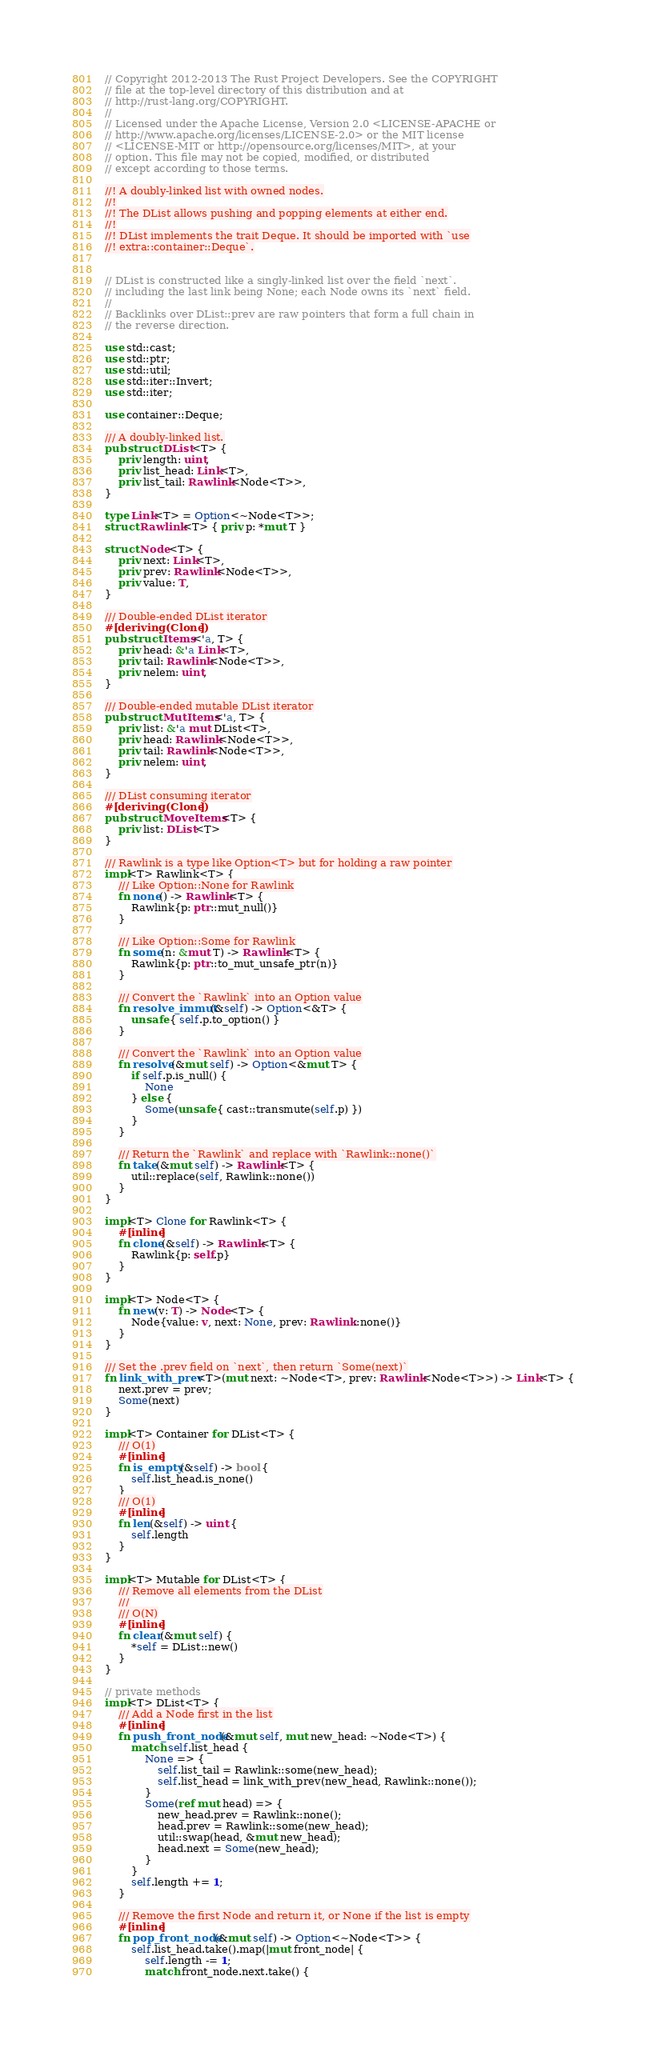Convert code to text. <code><loc_0><loc_0><loc_500><loc_500><_Rust_>// Copyright 2012-2013 The Rust Project Developers. See the COPYRIGHT
// file at the top-level directory of this distribution and at
// http://rust-lang.org/COPYRIGHT.
//
// Licensed under the Apache License, Version 2.0 <LICENSE-APACHE or
// http://www.apache.org/licenses/LICENSE-2.0> or the MIT license
// <LICENSE-MIT or http://opensource.org/licenses/MIT>, at your
// option. This file may not be copied, modified, or distributed
// except according to those terms.

//! A doubly-linked list with owned nodes.
//!
//! The DList allows pushing and popping elements at either end.
//!
//! DList implements the trait Deque. It should be imported with `use
//! extra::container::Deque`.


// DList is constructed like a singly-linked list over the field `next`.
// including the last link being None; each Node owns its `next` field.
//
// Backlinks over DList::prev are raw pointers that form a full chain in
// the reverse direction.

use std::cast;
use std::ptr;
use std::util;
use std::iter::Invert;
use std::iter;

use container::Deque;

/// A doubly-linked list.
pub struct DList<T> {
    priv length: uint,
    priv list_head: Link<T>,
    priv list_tail: Rawlink<Node<T>>,
}

type Link<T> = Option<~Node<T>>;
struct Rawlink<T> { priv p: *mut T }

struct Node<T> {
    priv next: Link<T>,
    priv prev: Rawlink<Node<T>>,
    priv value: T,
}

/// Double-ended DList iterator
#[deriving(Clone)]
pub struct Items<'a, T> {
    priv head: &'a Link<T>,
    priv tail: Rawlink<Node<T>>,
    priv nelem: uint,
}

/// Double-ended mutable DList iterator
pub struct MutItems<'a, T> {
    priv list: &'a mut DList<T>,
    priv head: Rawlink<Node<T>>,
    priv tail: Rawlink<Node<T>>,
    priv nelem: uint,
}

/// DList consuming iterator
#[deriving(Clone)]
pub struct MoveItems<T> {
    priv list: DList<T>
}

/// Rawlink is a type like Option<T> but for holding a raw pointer
impl<T> Rawlink<T> {
    /// Like Option::None for Rawlink
    fn none() -> Rawlink<T> {
        Rawlink{p: ptr::mut_null()}
    }

    /// Like Option::Some for Rawlink
    fn some(n: &mut T) -> Rawlink<T> {
        Rawlink{p: ptr::to_mut_unsafe_ptr(n)}
    }

    /// Convert the `Rawlink` into an Option value
    fn resolve_immut(&self) -> Option<&T> {
        unsafe { self.p.to_option() }
    }

    /// Convert the `Rawlink` into an Option value
    fn resolve(&mut self) -> Option<&mut T> {
        if self.p.is_null() {
            None
        } else {
            Some(unsafe { cast::transmute(self.p) })
        }
    }

    /// Return the `Rawlink` and replace with `Rawlink::none()`
    fn take(&mut self) -> Rawlink<T> {
        util::replace(self, Rawlink::none())
    }
}

impl<T> Clone for Rawlink<T> {
    #[inline]
    fn clone(&self) -> Rawlink<T> {
        Rawlink{p: self.p}
    }
}

impl<T> Node<T> {
    fn new(v: T) -> Node<T> {
        Node{value: v, next: None, prev: Rawlink::none()}
    }
}

/// Set the .prev field on `next`, then return `Some(next)`
fn link_with_prev<T>(mut next: ~Node<T>, prev: Rawlink<Node<T>>) -> Link<T> {
    next.prev = prev;
    Some(next)
}

impl<T> Container for DList<T> {
    /// O(1)
    #[inline]
    fn is_empty(&self) -> bool {
        self.list_head.is_none()
    }
    /// O(1)
    #[inline]
    fn len(&self) -> uint {
        self.length
    }
}

impl<T> Mutable for DList<T> {
    /// Remove all elements from the DList
    ///
    /// O(N)
    #[inline]
    fn clear(&mut self) {
        *self = DList::new()
    }
}

// private methods
impl<T> DList<T> {
    /// Add a Node first in the list
    #[inline]
    fn push_front_node(&mut self, mut new_head: ~Node<T>) {
        match self.list_head {
            None => {
                self.list_tail = Rawlink::some(new_head);
                self.list_head = link_with_prev(new_head, Rawlink::none());
            }
            Some(ref mut head) => {
                new_head.prev = Rawlink::none();
                head.prev = Rawlink::some(new_head);
                util::swap(head, &mut new_head);
                head.next = Some(new_head);
            }
        }
        self.length += 1;
    }

    /// Remove the first Node and return it, or None if the list is empty
    #[inline]
    fn pop_front_node(&mut self) -> Option<~Node<T>> {
        self.list_head.take().map(|mut front_node| {
            self.length -= 1;
            match front_node.next.take() {</code> 